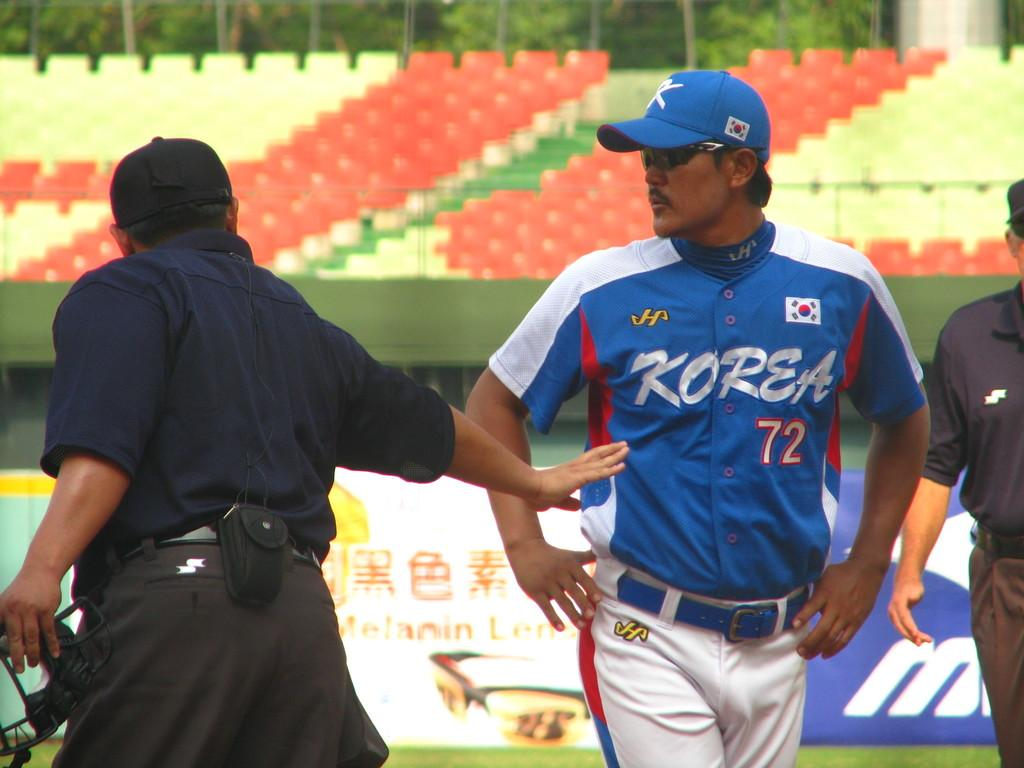Provide a one-sentence caption for the provided image. Baseball player for Korea walking off the field. 